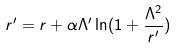<formula> <loc_0><loc_0><loc_500><loc_500>r ^ { \prime } = r + \alpha \Lambda ^ { \prime } \ln ( 1 + \frac { \Lambda ^ { 2 } } { r ^ { \prime } } )</formula> 